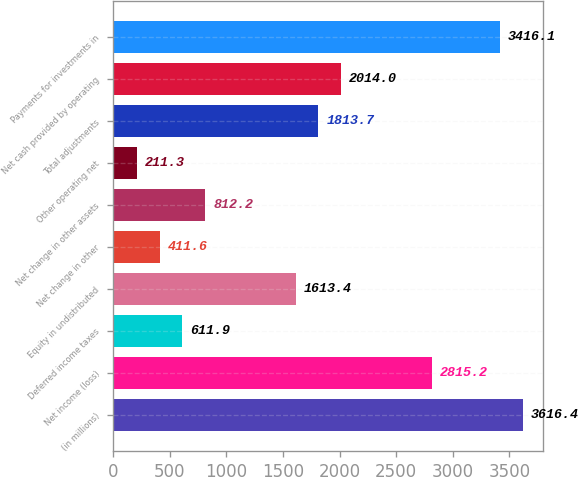Convert chart. <chart><loc_0><loc_0><loc_500><loc_500><bar_chart><fcel>(in millions)<fcel>Net income (loss)<fcel>Deferred income taxes<fcel>Equity in undistributed<fcel>Net change in other<fcel>Net change in other assets<fcel>Other operating net<fcel>Total adjustments<fcel>Net cash provided by operating<fcel>Payments for investments in<nl><fcel>3616.4<fcel>2815.2<fcel>611.9<fcel>1613.4<fcel>411.6<fcel>812.2<fcel>211.3<fcel>1813.7<fcel>2014<fcel>3416.1<nl></chart> 